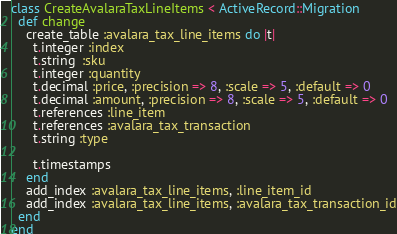<code> <loc_0><loc_0><loc_500><loc_500><_Ruby_>class CreateAvalaraTaxLineItems < ActiveRecord::Migration
  def change
    create_table :avalara_tax_line_items do |t|
      t.integer :index
      t.string  :sku
      t.integer :quantity
      t.decimal :price, :precision => 8, :scale => 5, :default => 0
      t.decimal :amount, :precision => 8, :scale => 5, :default => 0
      t.references :line_item
      t.references :avalara_tax_transaction
      t.string :type

      t.timestamps
    end
    add_index :avalara_tax_line_items, :line_item_id
    add_index :avalara_tax_line_items, :avalara_tax_transaction_id
  end
end
</code> 